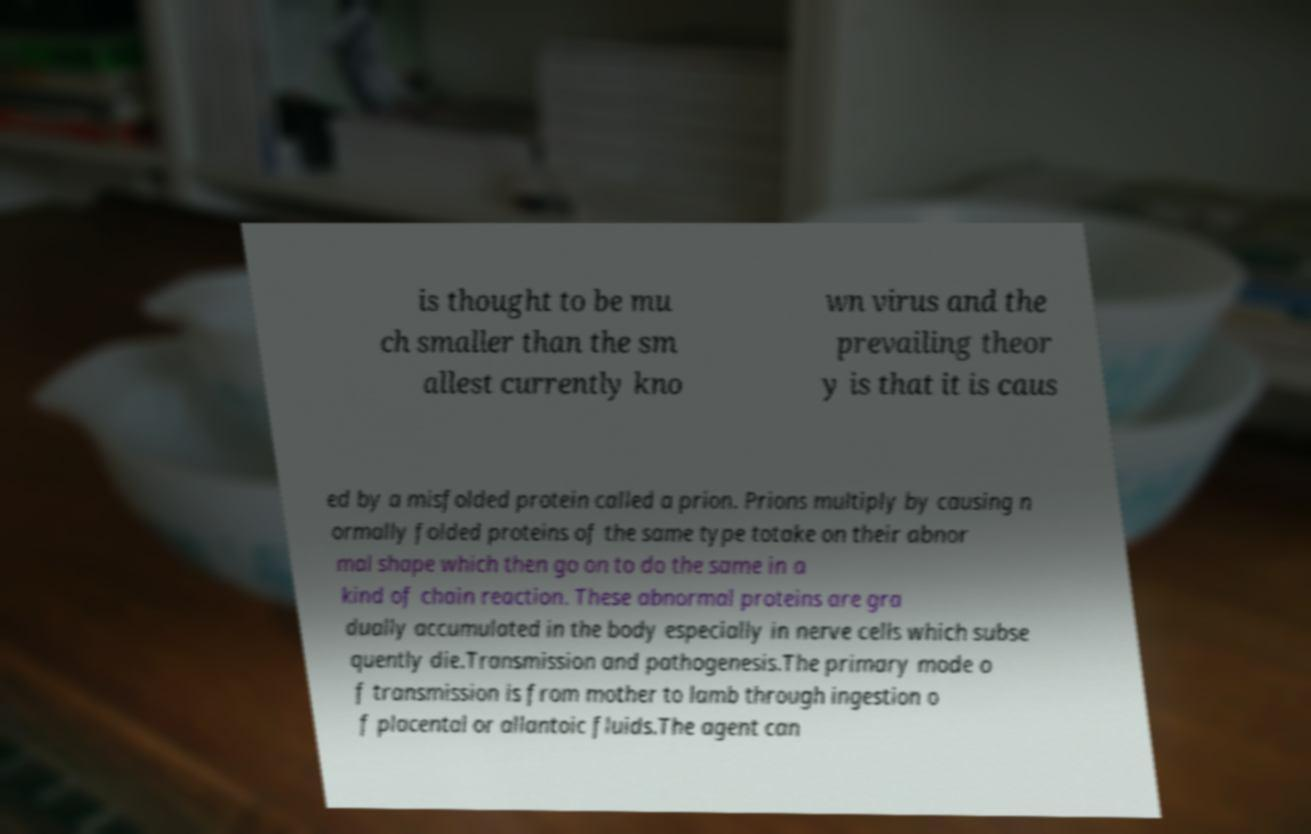For documentation purposes, I need the text within this image transcribed. Could you provide that? is thought to be mu ch smaller than the sm allest currently kno wn virus and the prevailing theor y is that it is caus ed by a misfolded protein called a prion. Prions multiply by causing n ormally folded proteins of the same type totake on their abnor mal shape which then go on to do the same in a kind of chain reaction. These abnormal proteins are gra dually accumulated in the body especially in nerve cells which subse quently die.Transmission and pathogenesis.The primary mode o f transmission is from mother to lamb through ingestion o f placental or allantoic fluids.The agent can 